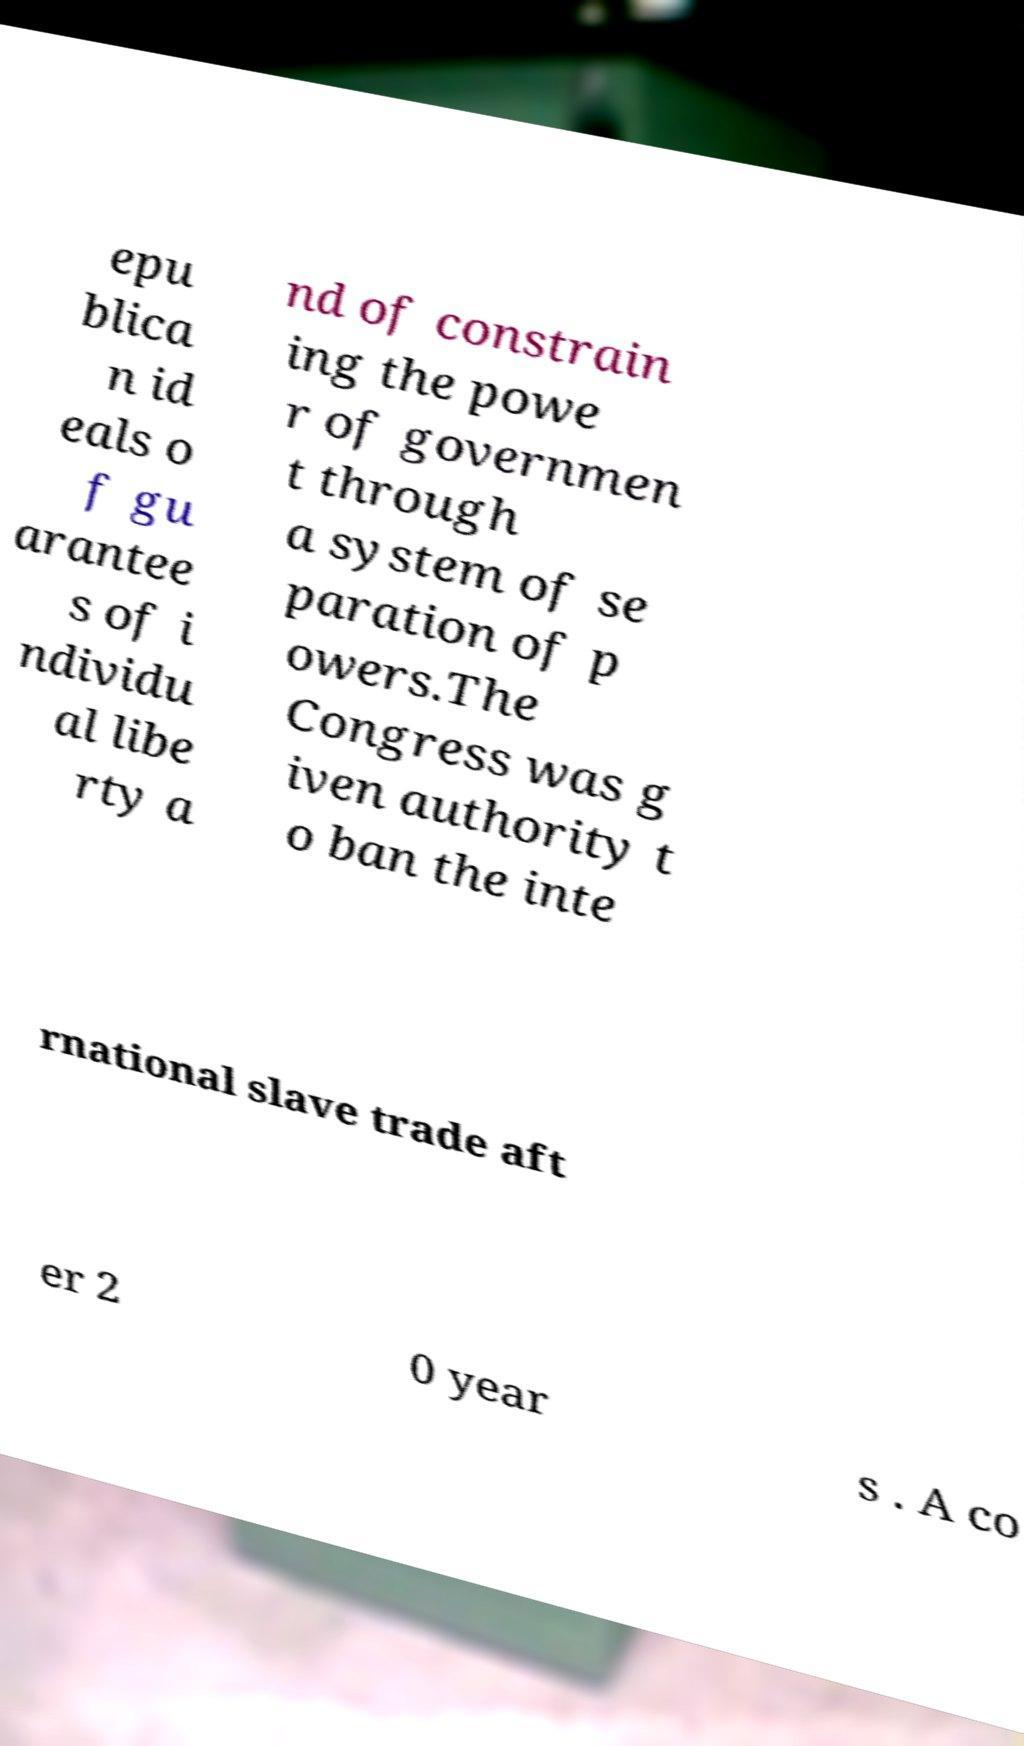Could you assist in decoding the text presented in this image and type it out clearly? epu blica n id eals o f gu arantee s of i ndividu al libe rty a nd of constrain ing the powe r of governmen t through a system of se paration of p owers.The Congress was g iven authority t o ban the inte rnational slave trade aft er 2 0 year s . A co 